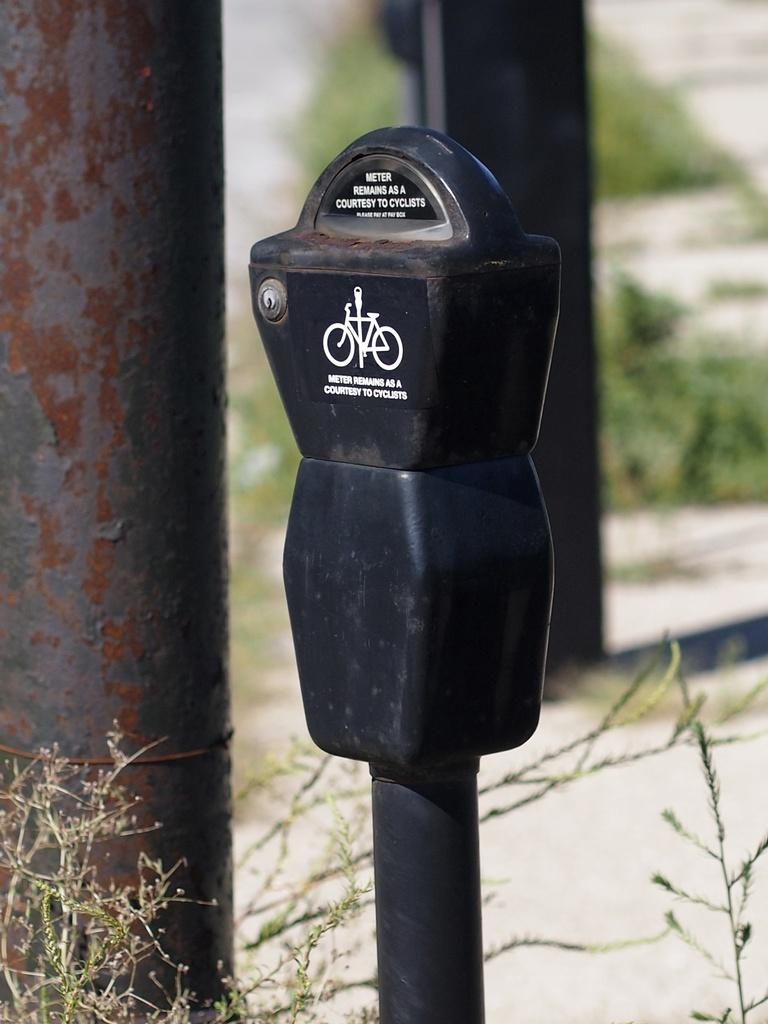<image>
Present a compact description of the photo's key features. A black parking meter states that it remains as a courtesy to cyclists. 